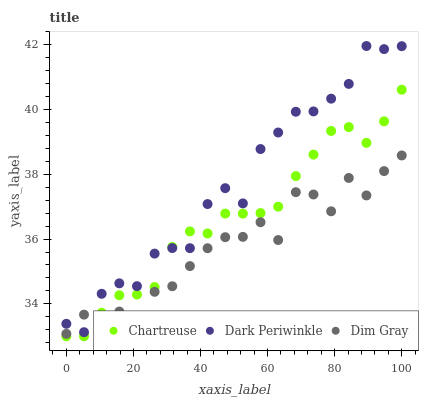Does Dim Gray have the minimum area under the curve?
Answer yes or no. Yes. Does Dark Periwinkle have the maximum area under the curve?
Answer yes or no. Yes. Does Dark Periwinkle have the minimum area under the curve?
Answer yes or no. No. Does Dim Gray have the maximum area under the curve?
Answer yes or no. No. Is Chartreuse the smoothest?
Answer yes or no. Yes. Is Dim Gray the roughest?
Answer yes or no. Yes. Is Dark Periwinkle the smoothest?
Answer yes or no. No. Is Dark Periwinkle the roughest?
Answer yes or no. No. Does Chartreuse have the lowest value?
Answer yes or no. Yes. Does Dim Gray have the lowest value?
Answer yes or no. No. Does Dark Periwinkle have the highest value?
Answer yes or no. Yes. Does Dim Gray have the highest value?
Answer yes or no. No. Does Dim Gray intersect Dark Periwinkle?
Answer yes or no. Yes. Is Dim Gray less than Dark Periwinkle?
Answer yes or no. No. Is Dim Gray greater than Dark Periwinkle?
Answer yes or no. No. 